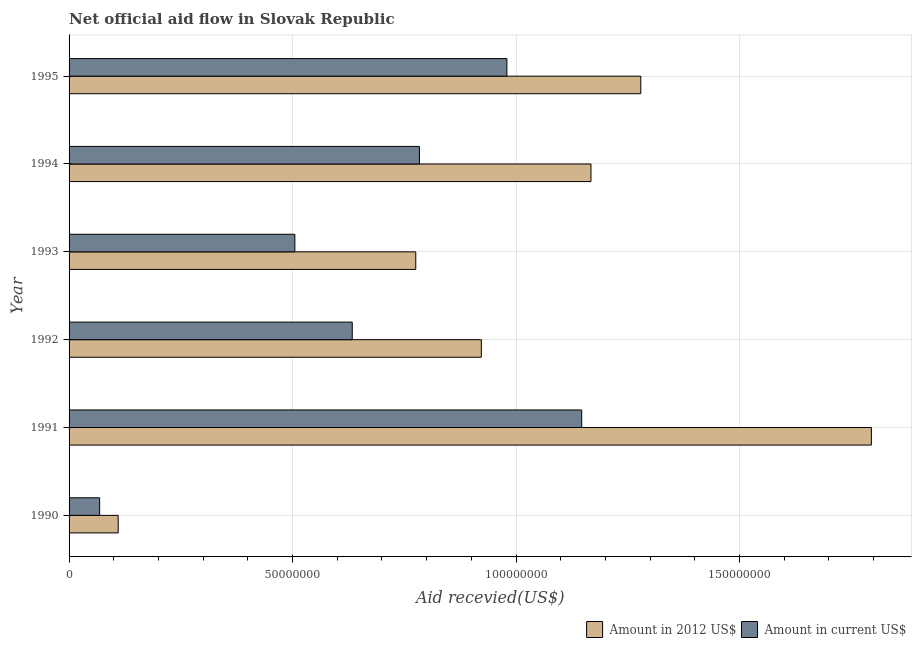How many different coloured bars are there?
Offer a very short reply. 2. Are the number of bars per tick equal to the number of legend labels?
Your answer should be compact. Yes. Are the number of bars on each tick of the Y-axis equal?
Your answer should be compact. Yes. How many bars are there on the 6th tick from the bottom?
Ensure brevity in your answer.  2. What is the label of the 4th group of bars from the top?
Your answer should be very brief. 1992. In how many cases, is the number of bars for a given year not equal to the number of legend labels?
Your answer should be very brief. 0. What is the amount of aid received(expressed in 2012 us$) in 1995?
Make the answer very short. 1.28e+08. Across all years, what is the maximum amount of aid received(expressed in us$)?
Your response must be concise. 1.15e+08. Across all years, what is the minimum amount of aid received(expressed in us$)?
Your answer should be compact. 6.84e+06. What is the total amount of aid received(expressed in 2012 us$) in the graph?
Ensure brevity in your answer.  6.05e+08. What is the difference between the amount of aid received(expressed in us$) in 1992 and that in 1993?
Your answer should be compact. 1.28e+07. What is the difference between the amount of aid received(expressed in 2012 us$) in 1991 and the amount of aid received(expressed in us$) in 1990?
Your response must be concise. 1.73e+08. What is the average amount of aid received(expressed in 2012 us$) per year?
Your answer should be very brief. 1.01e+08. In the year 1991, what is the difference between the amount of aid received(expressed in us$) and amount of aid received(expressed in 2012 us$)?
Offer a very short reply. -6.48e+07. In how many years, is the amount of aid received(expressed in us$) greater than 90000000 US$?
Keep it short and to the point. 2. What is the ratio of the amount of aid received(expressed in 2012 us$) in 1991 to that in 1995?
Make the answer very short. 1.4. Is the difference between the amount of aid received(expressed in 2012 us$) in 1990 and 1993 greater than the difference between the amount of aid received(expressed in us$) in 1990 and 1993?
Offer a terse response. No. What is the difference between the highest and the second highest amount of aid received(expressed in 2012 us$)?
Your response must be concise. 5.16e+07. What is the difference between the highest and the lowest amount of aid received(expressed in 2012 us$)?
Provide a short and direct response. 1.69e+08. What does the 1st bar from the top in 1992 represents?
Your answer should be very brief. Amount in current US$. What does the 1st bar from the bottom in 1992 represents?
Give a very brief answer. Amount in 2012 US$. Are all the bars in the graph horizontal?
Your response must be concise. Yes. Are the values on the major ticks of X-axis written in scientific E-notation?
Your answer should be compact. No. Does the graph contain any zero values?
Provide a succinct answer. No. Where does the legend appear in the graph?
Make the answer very short. Bottom right. How many legend labels are there?
Ensure brevity in your answer.  2. What is the title of the graph?
Offer a very short reply. Net official aid flow in Slovak Republic. Does "Primary education" appear as one of the legend labels in the graph?
Provide a short and direct response. No. What is the label or title of the X-axis?
Provide a succinct answer. Aid recevied(US$). What is the Aid recevied(US$) of Amount in 2012 US$ in 1990?
Ensure brevity in your answer.  1.10e+07. What is the Aid recevied(US$) in Amount in current US$ in 1990?
Provide a succinct answer. 6.84e+06. What is the Aid recevied(US$) of Amount in 2012 US$ in 1991?
Make the answer very short. 1.80e+08. What is the Aid recevied(US$) in Amount in current US$ in 1991?
Your answer should be compact. 1.15e+08. What is the Aid recevied(US$) of Amount in 2012 US$ in 1992?
Offer a very short reply. 9.22e+07. What is the Aid recevied(US$) in Amount in current US$ in 1992?
Provide a succinct answer. 6.34e+07. What is the Aid recevied(US$) in Amount in 2012 US$ in 1993?
Offer a terse response. 7.76e+07. What is the Aid recevied(US$) of Amount in current US$ in 1993?
Make the answer very short. 5.05e+07. What is the Aid recevied(US$) of Amount in 2012 US$ in 1994?
Keep it short and to the point. 1.17e+08. What is the Aid recevied(US$) in Amount in current US$ in 1994?
Provide a succinct answer. 7.84e+07. What is the Aid recevied(US$) in Amount in 2012 US$ in 1995?
Your answer should be compact. 1.28e+08. What is the Aid recevied(US$) of Amount in current US$ in 1995?
Provide a succinct answer. 9.80e+07. Across all years, what is the maximum Aid recevied(US$) of Amount in 2012 US$?
Your response must be concise. 1.80e+08. Across all years, what is the maximum Aid recevied(US$) of Amount in current US$?
Make the answer very short. 1.15e+08. Across all years, what is the minimum Aid recevied(US$) in Amount in 2012 US$?
Your response must be concise. 1.10e+07. Across all years, what is the minimum Aid recevied(US$) in Amount in current US$?
Your answer should be very brief. 6.84e+06. What is the total Aid recevied(US$) of Amount in 2012 US$ in the graph?
Give a very brief answer. 6.05e+08. What is the total Aid recevied(US$) of Amount in current US$ in the graph?
Provide a succinct answer. 4.12e+08. What is the difference between the Aid recevied(US$) of Amount in 2012 US$ in 1990 and that in 1991?
Give a very brief answer. -1.69e+08. What is the difference between the Aid recevied(US$) of Amount in current US$ in 1990 and that in 1991?
Ensure brevity in your answer.  -1.08e+08. What is the difference between the Aid recevied(US$) in Amount in 2012 US$ in 1990 and that in 1992?
Provide a short and direct response. -8.12e+07. What is the difference between the Aid recevied(US$) of Amount in current US$ in 1990 and that in 1992?
Make the answer very short. -5.65e+07. What is the difference between the Aid recevied(US$) in Amount in 2012 US$ in 1990 and that in 1993?
Ensure brevity in your answer.  -6.66e+07. What is the difference between the Aid recevied(US$) in Amount in current US$ in 1990 and that in 1993?
Keep it short and to the point. -4.37e+07. What is the difference between the Aid recevied(US$) in Amount in 2012 US$ in 1990 and that in 1994?
Make the answer very short. -1.06e+08. What is the difference between the Aid recevied(US$) of Amount in current US$ in 1990 and that in 1994?
Offer a terse response. -7.16e+07. What is the difference between the Aid recevied(US$) of Amount in 2012 US$ in 1990 and that in 1995?
Your answer should be very brief. -1.17e+08. What is the difference between the Aid recevied(US$) of Amount in current US$ in 1990 and that in 1995?
Give a very brief answer. -9.11e+07. What is the difference between the Aid recevied(US$) in Amount in 2012 US$ in 1991 and that in 1992?
Your answer should be very brief. 8.73e+07. What is the difference between the Aid recevied(US$) of Amount in current US$ in 1991 and that in 1992?
Provide a short and direct response. 5.13e+07. What is the difference between the Aid recevied(US$) of Amount in 2012 US$ in 1991 and that in 1993?
Your answer should be compact. 1.02e+08. What is the difference between the Aid recevied(US$) in Amount in current US$ in 1991 and that in 1993?
Make the answer very short. 6.42e+07. What is the difference between the Aid recevied(US$) of Amount in 2012 US$ in 1991 and that in 1994?
Make the answer very short. 6.27e+07. What is the difference between the Aid recevied(US$) of Amount in current US$ in 1991 and that in 1994?
Provide a succinct answer. 3.63e+07. What is the difference between the Aid recevied(US$) of Amount in 2012 US$ in 1991 and that in 1995?
Offer a very short reply. 5.16e+07. What is the difference between the Aid recevied(US$) of Amount in current US$ in 1991 and that in 1995?
Provide a short and direct response. 1.67e+07. What is the difference between the Aid recevied(US$) in Amount in 2012 US$ in 1992 and that in 1993?
Provide a succinct answer. 1.47e+07. What is the difference between the Aid recevied(US$) in Amount in current US$ in 1992 and that in 1993?
Offer a very short reply. 1.28e+07. What is the difference between the Aid recevied(US$) in Amount in 2012 US$ in 1992 and that in 1994?
Offer a very short reply. -2.45e+07. What is the difference between the Aid recevied(US$) of Amount in current US$ in 1992 and that in 1994?
Your answer should be very brief. -1.50e+07. What is the difference between the Aid recevied(US$) of Amount in 2012 US$ in 1992 and that in 1995?
Keep it short and to the point. -3.57e+07. What is the difference between the Aid recevied(US$) of Amount in current US$ in 1992 and that in 1995?
Provide a short and direct response. -3.46e+07. What is the difference between the Aid recevied(US$) of Amount in 2012 US$ in 1993 and that in 1994?
Provide a succinct answer. -3.92e+07. What is the difference between the Aid recevied(US$) in Amount in current US$ in 1993 and that in 1994?
Provide a succinct answer. -2.79e+07. What is the difference between the Aid recevied(US$) in Amount in 2012 US$ in 1993 and that in 1995?
Offer a very short reply. -5.04e+07. What is the difference between the Aid recevied(US$) in Amount in current US$ in 1993 and that in 1995?
Offer a very short reply. -4.74e+07. What is the difference between the Aid recevied(US$) in Amount in 2012 US$ in 1994 and that in 1995?
Provide a short and direct response. -1.12e+07. What is the difference between the Aid recevied(US$) of Amount in current US$ in 1994 and that in 1995?
Ensure brevity in your answer.  -1.96e+07. What is the difference between the Aid recevied(US$) of Amount in 2012 US$ in 1990 and the Aid recevied(US$) of Amount in current US$ in 1991?
Provide a short and direct response. -1.04e+08. What is the difference between the Aid recevied(US$) in Amount in 2012 US$ in 1990 and the Aid recevied(US$) in Amount in current US$ in 1992?
Give a very brief answer. -5.24e+07. What is the difference between the Aid recevied(US$) of Amount in 2012 US$ in 1990 and the Aid recevied(US$) of Amount in current US$ in 1993?
Your response must be concise. -3.95e+07. What is the difference between the Aid recevied(US$) in Amount in 2012 US$ in 1990 and the Aid recevied(US$) in Amount in current US$ in 1994?
Offer a terse response. -6.74e+07. What is the difference between the Aid recevied(US$) of Amount in 2012 US$ in 1990 and the Aid recevied(US$) of Amount in current US$ in 1995?
Keep it short and to the point. -8.70e+07. What is the difference between the Aid recevied(US$) of Amount in 2012 US$ in 1991 and the Aid recevied(US$) of Amount in current US$ in 1992?
Your answer should be compact. 1.16e+08. What is the difference between the Aid recevied(US$) of Amount in 2012 US$ in 1991 and the Aid recevied(US$) of Amount in current US$ in 1993?
Offer a very short reply. 1.29e+08. What is the difference between the Aid recevied(US$) of Amount in 2012 US$ in 1991 and the Aid recevied(US$) of Amount in current US$ in 1994?
Your answer should be very brief. 1.01e+08. What is the difference between the Aid recevied(US$) in Amount in 2012 US$ in 1991 and the Aid recevied(US$) in Amount in current US$ in 1995?
Provide a short and direct response. 8.16e+07. What is the difference between the Aid recevied(US$) of Amount in 2012 US$ in 1992 and the Aid recevied(US$) of Amount in current US$ in 1993?
Keep it short and to the point. 4.17e+07. What is the difference between the Aid recevied(US$) in Amount in 2012 US$ in 1992 and the Aid recevied(US$) in Amount in current US$ in 1994?
Offer a very short reply. 1.38e+07. What is the difference between the Aid recevied(US$) of Amount in 2012 US$ in 1992 and the Aid recevied(US$) of Amount in current US$ in 1995?
Your response must be concise. -5.72e+06. What is the difference between the Aid recevied(US$) in Amount in 2012 US$ in 1993 and the Aid recevied(US$) in Amount in current US$ in 1994?
Your answer should be compact. -8.20e+05. What is the difference between the Aid recevied(US$) of Amount in 2012 US$ in 1993 and the Aid recevied(US$) of Amount in current US$ in 1995?
Offer a terse response. -2.04e+07. What is the difference between the Aid recevied(US$) of Amount in 2012 US$ in 1994 and the Aid recevied(US$) of Amount in current US$ in 1995?
Give a very brief answer. 1.88e+07. What is the average Aid recevied(US$) of Amount in 2012 US$ per year?
Your response must be concise. 1.01e+08. What is the average Aid recevied(US$) of Amount in current US$ per year?
Offer a very short reply. 6.86e+07. In the year 1990, what is the difference between the Aid recevied(US$) in Amount in 2012 US$ and Aid recevied(US$) in Amount in current US$?
Offer a very short reply. 4.15e+06. In the year 1991, what is the difference between the Aid recevied(US$) of Amount in 2012 US$ and Aid recevied(US$) of Amount in current US$?
Your answer should be very brief. 6.48e+07. In the year 1992, what is the difference between the Aid recevied(US$) in Amount in 2012 US$ and Aid recevied(US$) in Amount in current US$?
Offer a terse response. 2.89e+07. In the year 1993, what is the difference between the Aid recevied(US$) in Amount in 2012 US$ and Aid recevied(US$) in Amount in current US$?
Ensure brevity in your answer.  2.70e+07. In the year 1994, what is the difference between the Aid recevied(US$) of Amount in 2012 US$ and Aid recevied(US$) of Amount in current US$?
Your answer should be compact. 3.84e+07. In the year 1995, what is the difference between the Aid recevied(US$) of Amount in 2012 US$ and Aid recevied(US$) of Amount in current US$?
Offer a terse response. 3.00e+07. What is the ratio of the Aid recevied(US$) of Amount in 2012 US$ in 1990 to that in 1991?
Your answer should be very brief. 0.06. What is the ratio of the Aid recevied(US$) of Amount in current US$ in 1990 to that in 1991?
Keep it short and to the point. 0.06. What is the ratio of the Aid recevied(US$) of Amount in 2012 US$ in 1990 to that in 1992?
Keep it short and to the point. 0.12. What is the ratio of the Aid recevied(US$) in Amount in current US$ in 1990 to that in 1992?
Ensure brevity in your answer.  0.11. What is the ratio of the Aid recevied(US$) of Amount in 2012 US$ in 1990 to that in 1993?
Offer a very short reply. 0.14. What is the ratio of the Aid recevied(US$) in Amount in current US$ in 1990 to that in 1993?
Keep it short and to the point. 0.14. What is the ratio of the Aid recevied(US$) in Amount in 2012 US$ in 1990 to that in 1994?
Provide a short and direct response. 0.09. What is the ratio of the Aid recevied(US$) of Amount in current US$ in 1990 to that in 1994?
Your answer should be very brief. 0.09. What is the ratio of the Aid recevied(US$) of Amount in 2012 US$ in 1990 to that in 1995?
Your response must be concise. 0.09. What is the ratio of the Aid recevied(US$) of Amount in current US$ in 1990 to that in 1995?
Offer a terse response. 0.07. What is the ratio of the Aid recevied(US$) of Amount in 2012 US$ in 1991 to that in 1992?
Provide a short and direct response. 1.95. What is the ratio of the Aid recevied(US$) of Amount in current US$ in 1991 to that in 1992?
Your answer should be very brief. 1.81. What is the ratio of the Aid recevied(US$) of Amount in 2012 US$ in 1991 to that in 1993?
Keep it short and to the point. 2.31. What is the ratio of the Aid recevied(US$) of Amount in current US$ in 1991 to that in 1993?
Give a very brief answer. 2.27. What is the ratio of the Aid recevied(US$) of Amount in 2012 US$ in 1991 to that in 1994?
Keep it short and to the point. 1.54. What is the ratio of the Aid recevied(US$) of Amount in current US$ in 1991 to that in 1994?
Provide a succinct answer. 1.46. What is the ratio of the Aid recevied(US$) in Amount in 2012 US$ in 1991 to that in 1995?
Keep it short and to the point. 1.4. What is the ratio of the Aid recevied(US$) of Amount in current US$ in 1991 to that in 1995?
Offer a terse response. 1.17. What is the ratio of the Aid recevied(US$) in Amount in 2012 US$ in 1992 to that in 1993?
Offer a terse response. 1.19. What is the ratio of the Aid recevied(US$) of Amount in current US$ in 1992 to that in 1993?
Provide a succinct answer. 1.25. What is the ratio of the Aid recevied(US$) of Amount in 2012 US$ in 1992 to that in 1994?
Give a very brief answer. 0.79. What is the ratio of the Aid recevied(US$) of Amount in current US$ in 1992 to that in 1994?
Offer a very short reply. 0.81. What is the ratio of the Aid recevied(US$) in Amount in 2012 US$ in 1992 to that in 1995?
Your answer should be very brief. 0.72. What is the ratio of the Aid recevied(US$) of Amount in current US$ in 1992 to that in 1995?
Provide a short and direct response. 0.65. What is the ratio of the Aid recevied(US$) in Amount in 2012 US$ in 1993 to that in 1994?
Offer a terse response. 0.66. What is the ratio of the Aid recevied(US$) of Amount in current US$ in 1993 to that in 1994?
Keep it short and to the point. 0.64. What is the ratio of the Aid recevied(US$) in Amount in 2012 US$ in 1993 to that in 1995?
Your response must be concise. 0.61. What is the ratio of the Aid recevied(US$) of Amount in current US$ in 1993 to that in 1995?
Your response must be concise. 0.52. What is the ratio of the Aid recevied(US$) of Amount in 2012 US$ in 1994 to that in 1995?
Your answer should be very brief. 0.91. What is the ratio of the Aid recevied(US$) in Amount in current US$ in 1994 to that in 1995?
Ensure brevity in your answer.  0.8. What is the difference between the highest and the second highest Aid recevied(US$) of Amount in 2012 US$?
Offer a very short reply. 5.16e+07. What is the difference between the highest and the second highest Aid recevied(US$) of Amount in current US$?
Offer a terse response. 1.67e+07. What is the difference between the highest and the lowest Aid recevied(US$) in Amount in 2012 US$?
Ensure brevity in your answer.  1.69e+08. What is the difference between the highest and the lowest Aid recevied(US$) of Amount in current US$?
Provide a succinct answer. 1.08e+08. 